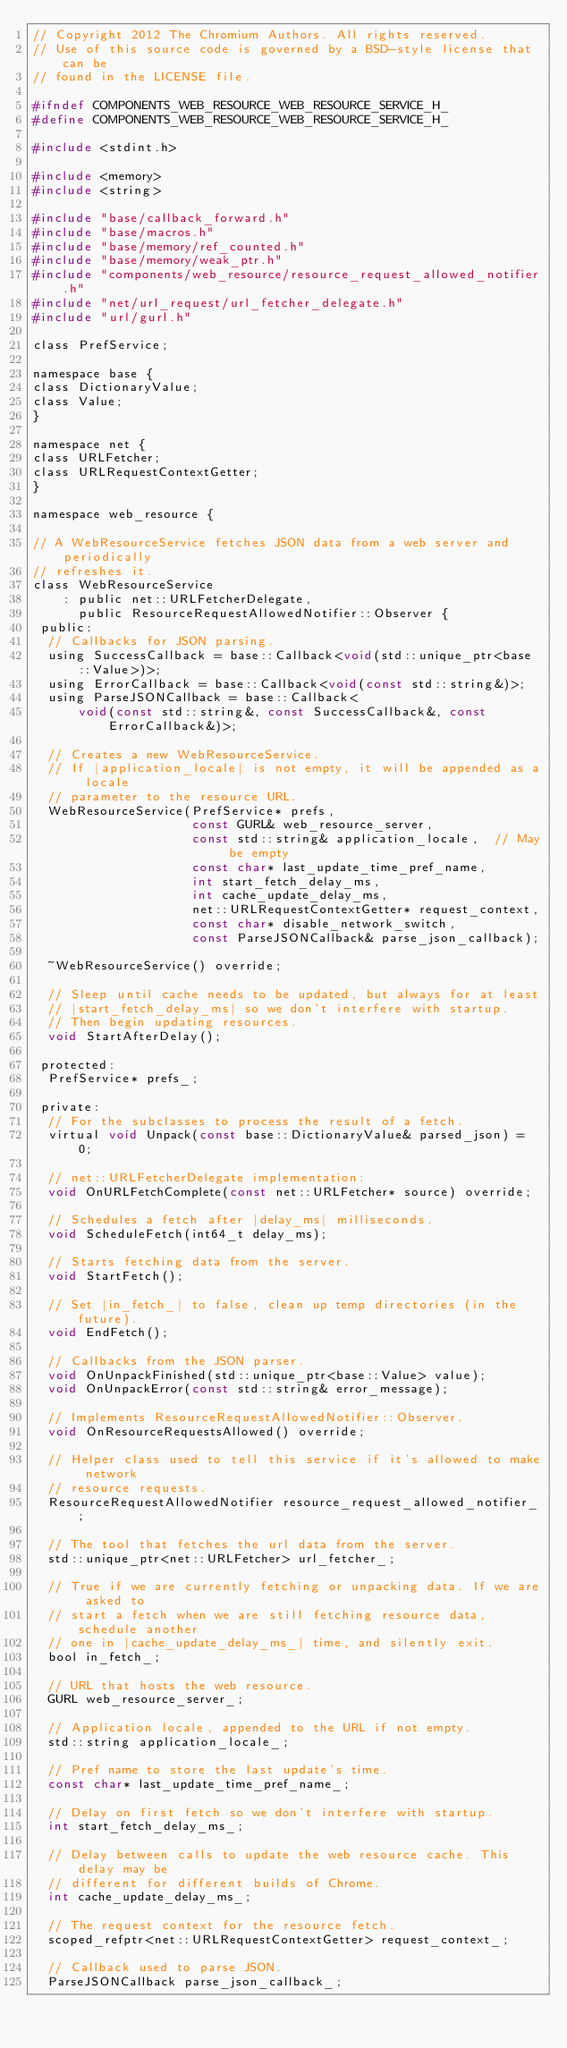<code> <loc_0><loc_0><loc_500><loc_500><_C_>// Copyright 2012 The Chromium Authors. All rights reserved.
// Use of this source code is governed by a BSD-style license that can be
// found in the LICENSE file.

#ifndef COMPONENTS_WEB_RESOURCE_WEB_RESOURCE_SERVICE_H_
#define COMPONENTS_WEB_RESOURCE_WEB_RESOURCE_SERVICE_H_

#include <stdint.h>

#include <memory>
#include <string>

#include "base/callback_forward.h"
#include "base/macros.h"
#include "base/memory/ref_counted.h"
#include "base/memory/weak_ptr.h"
#include "components/web_resource/resource_request_allowed_notifier.h"
#include "net/url_request/url_fetcher_delegate.h"
#include "url/gurl.h"

class PrefService;

namespace base {
class DictionaryValue;
class Value;
}

namespace net {
class URLFetcher;
class URLRequestContextGetter;
}

namespace web_resource {

// A WebResourceService fetches JSON data from a web server and periodically
// refreshes it.
class WebResourceService
    : public net::URLFetcherDelegate,
      public ResourceRequestAllowedNotifier::Observer {
 public:
  // Callbacks for JSON parsing.
  using SuccessCallback = base::Callback<void(std::unique_ptr<base::Value>)>;
  using ErrorCallback = base::Callback<void(const std::string&)>;
  using ParseJSONCallback = base::Callback<
      void(const std::string&, const SuccessCallback&, const ErrorCallback&)>;

  // Creates a new WebResourceService.
  // If |application_locale| is not empty, it will be appended as a locale
  // parameter to the resource URL.
  WebResourceService(PrefService* prefs,
                     const GURL& web_resource_server,
                     const std::string& application_locale,  // May be empty
                     const char* last_update_time_pref_name,
                     int start_fetch_delay_ms,
                     int cache_update_delay_ms,
                     net::URLRequestContextGetter* request_context,
                     const char* disable_network_switch,
                     const ParseJSONCallback& parse_json_callback);

  ~WebResourceService() override;

  // Sleep until cache needs to be updated, but always for at least
  // |start_fetch_delay_ms| so we don't interfere with startup.
  // Then begin updating resources.
  void StartAfterDelay();

 protected:
  PrefService* prefs_;

 private:
  // For the subclasses to process the result of a fetch.
  virtual void Unpack(const base::DictionaryValue& parsed_json) = 0;

  // net::URLFetcherDelegate implementation:
  void OnURLFetchComplete(const net::URLFetcher* source) override;

  // Schedules a fetch after |delay_ms| milliseconds.
  void ScheduleFetch(int64_t delay_ms);

  // Starts fetching data from the server.
  void StartFetch();

  // Set |in_fetch_| to false, clean up temp directories (in the future).
  void EndFetch();

  // Callbacks from the JSON parser.
  void OnUnpackFinished(std::unique_ptr<base::Value> value);
  void OnUnpackError(const std::string& error_message);

  // Implements ResourceRequestAllowedNotifier::Observer.
  void OnResourceRequestsAllowed() override;

  // Helper class used to tell this service if it's allowed to make network
  // resource requests.
  ResourceRequestAllowedNotifier resource_request_allowed_notifier_;

  // The tool that fetches the url data from the server.
  std::unique_ptr<net::URLFetcher> url_fetcher_;

  // True if we are currently fetching or unpacking data. If we are asked to
  // start a fetch when we are still fetching resource data, schedule another
  // one in |cache_update_delay_ms_| time, and silently exit.
  bool in_fetch_;

  // URL that hosts the web resource.
  GURL web_resource_server_;

  // Application locale, appended to the URL if not empty.
  std::string application_locale_;

  // Pref name to store the last update's time.
  const char* last_update_time_pref_name_;

  // Delay on first fetch so we don't interfere with startup.
  int start_fetch_delay_ms_;

  // Delay between calls to update the web resource cache. This delay may be
  // different for different builds of Chrome.
  int cache_update_delay_ms_;

  // The request context for the resource fetch.
  scoped_refptr<net::URLRequestContextGetter> request_context_;

  // Callback used to parse JSON.
  ParseJSONCallback parse_json_callback_;
</code> 